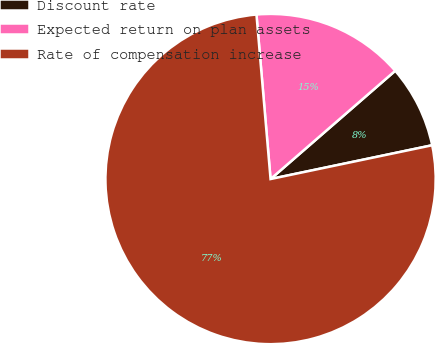Convert chart to OTSL. <chart><loc_0><loc_0><loc_500><loc_500><pie_chart><fcel>Discount rate<fcel>Expected return on plan assets<fcel>Rate of compensation increase<nl><fcel>8.1%<fcel>14.98%<fcel>76.92%<nl></chart> 